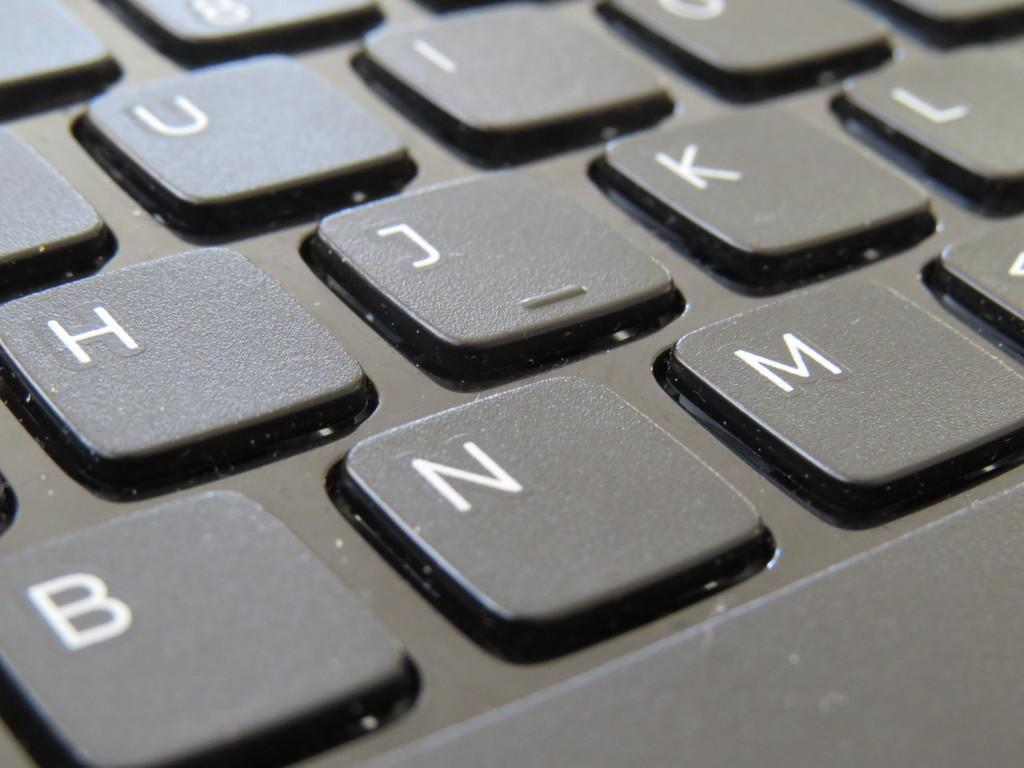Provide a one-sentence caption for the provided image. Black and white keyboard that contains letters on the buttons. 